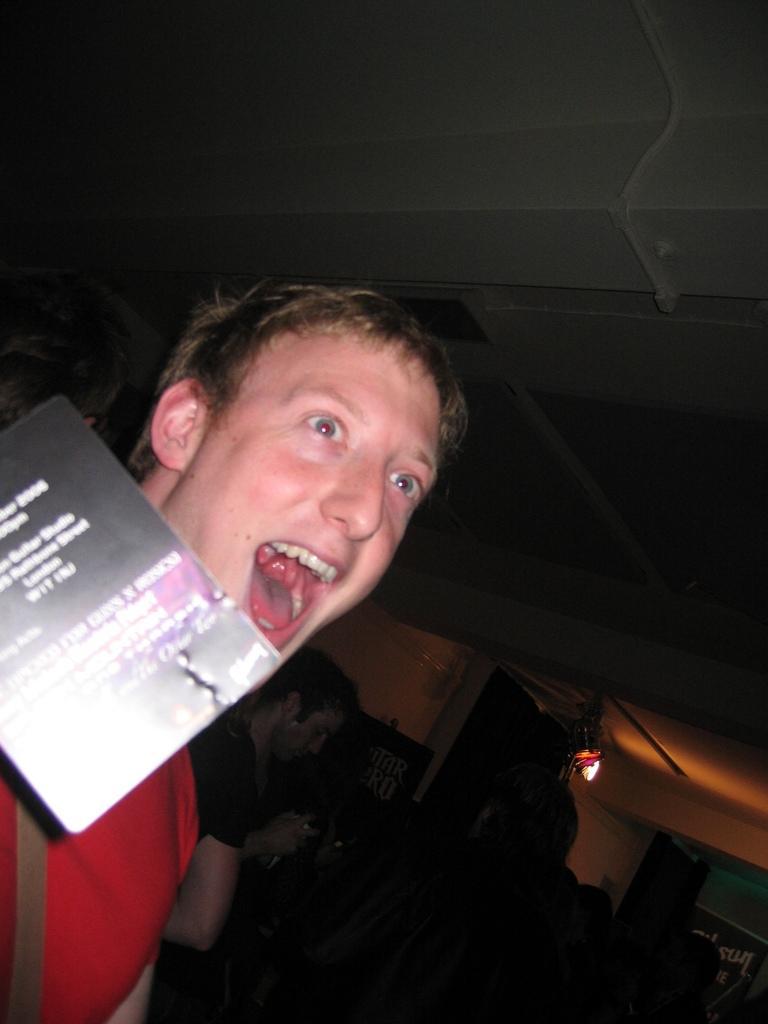In one or two sentences, can you explain what this image depicts? On the left side of the image we can see a person and poster. In the background of the image there are people, hoardings and walls. 